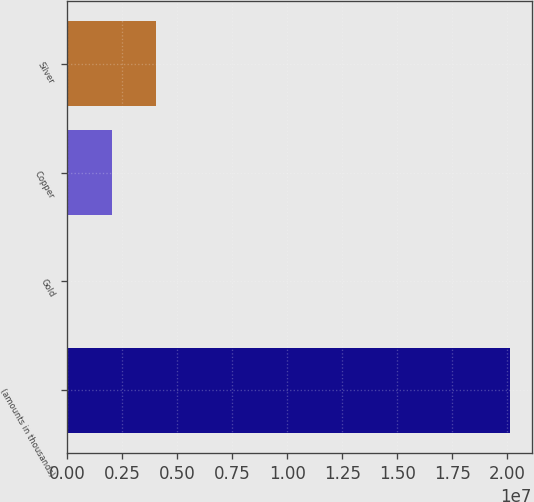<chart> <loc_0><loc_0><loc_500><loc_500><bar_chart><fcel>(amounts in thousands)<fcel>Gold<fcel>Copper<fcel>Silver<nl><fcel>2.0112e+07<fcel>14<fcel>2.01121e+06<fcel>4.02241e+06<nl></chart> 